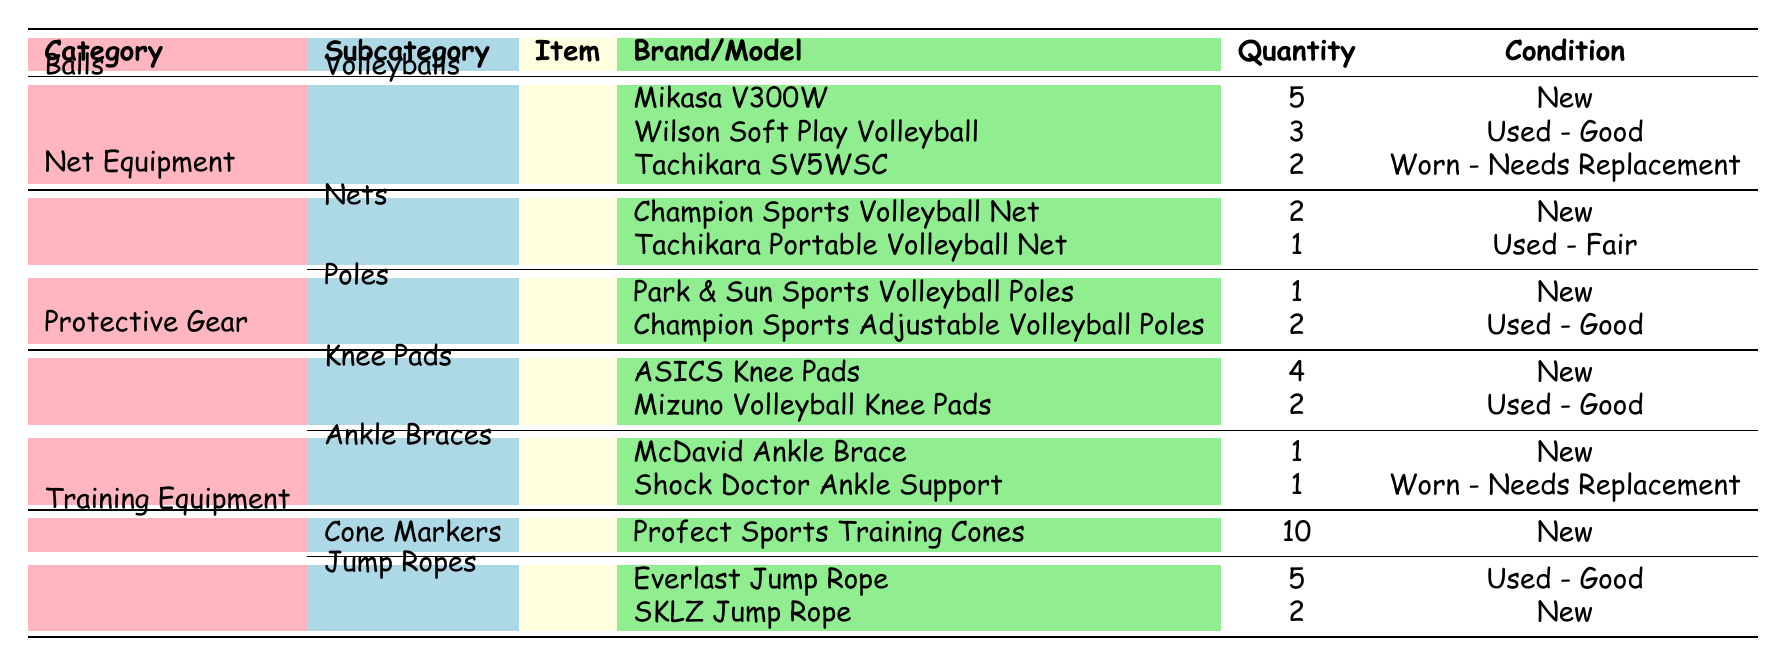What is the total quantity of Volleyballs available? There are three types of Volleyballs listed: Mikasa V300W (5), Wilson Soft Play Volleyball (3), and Tachikara SV5WSC (2). Adding them gives a total of 5 + 3 + 2 = 10.
Answer: 10 How many items in total fall under Protective Gear? There are two categories in Protective Gear: Knee Pads (ASICS Knee Pads with 4 and Mizuno Volleyball Knee Pads with 2) totaling 6, and Ankle Braces (McDavid Ankle Brace with 1 and Shock Doctor Ankle Support with 1) totaling 2. Adding these two categories gives 6 + 2 = 8.
Answer: 8 Is there any Volleyball equipment that is 'Worn - Needs Replacement'? The only item categorized as 'Worn - Needs Replacement' is Tachikara SV5WSC Volleyball (2) and Shock Doctor Ankle Support (1). Thus, the answer is yes.
Answer: Yes What is the combined quantity of new equipment available in the Training Equipment category? The Training Equipment has two types: Cone Markers (Profect Sports Training Cones with 10, which is new) and Jump Ropes. The Jump Ropes have one new item (SKLZ Jump Rope with 2). Therefore, adding these gives 10 (Cone Markers) + 2 = 12, but only the new items are counted, making the total 10 + 2 = 12.
Answer: 12 Which type of equipment has the highest quantity? Looking at the table, Volleyballs (total of 10) have the highest quantity compared to other categories. Balls are the only items in that category, which confirms it holds the maximum quantity overall.
Answer: Volleyballs What percentage of the total Volleyballs is in 'Used - Good' condition? The only Volleyballs in 'Used - Good' condition is Wilson Soft Play Volleyball (3 out of 10 Volleyballs). To find the percentage, calculate (3/10) * 100 = 30%.
Answer: 30% How many more knee pads are there than ankle braces? There are 6 Knee Pads (4 ASICS and 2 Mizuno) and 2 Ankle Braces (1 McDavid and 1 Shock Doctor). The difference is calculated as 6 - 2 = 4 more knee pads than ankle braces.
Answer: 4 Are there any items listed as 'Used - Fair' in the inventory? The only item listed as 'Used - Fair' is the Tachikara Portable Volleyball Net. Therefore, the answer is yes.
Answer: Yes 